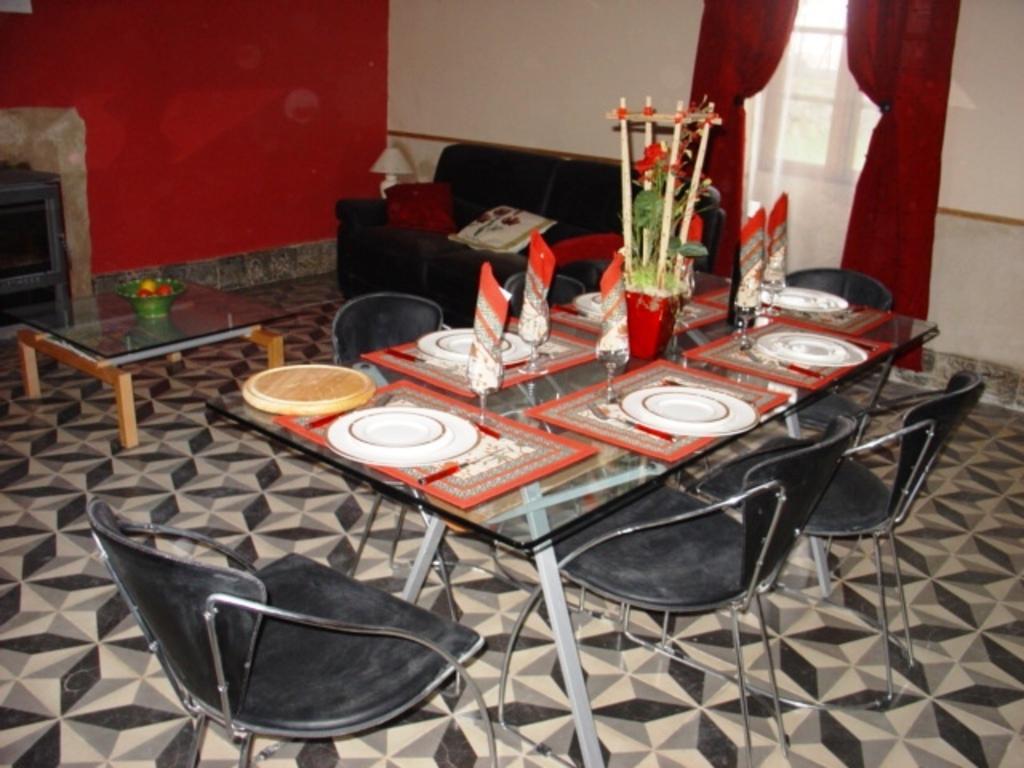Describe this image in one or two sentences. In the center of the image, we can see plates, spoons, glasses, napkins and a pot are placed on the table and in the background, we can see chairs, cushions on the sofa and there is a basket on the table. 